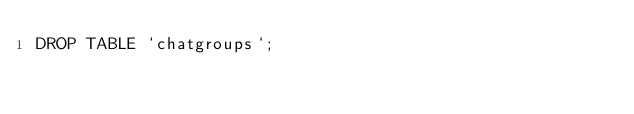<code> <loc_0><loc_0><loc_500><loc_500><_SQL_>DROP TABLE `chatgroups`;
</code> 